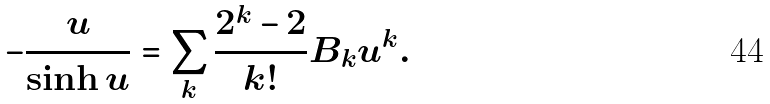<formula> <loc_0><loc_0><loc_500><loc_500>- \frac { u } { \sinh u } = \sum _ { k } \frac { 2 ^ { k } - 2 } { k ! } B _ { k } u ^ { k } .</formula> 